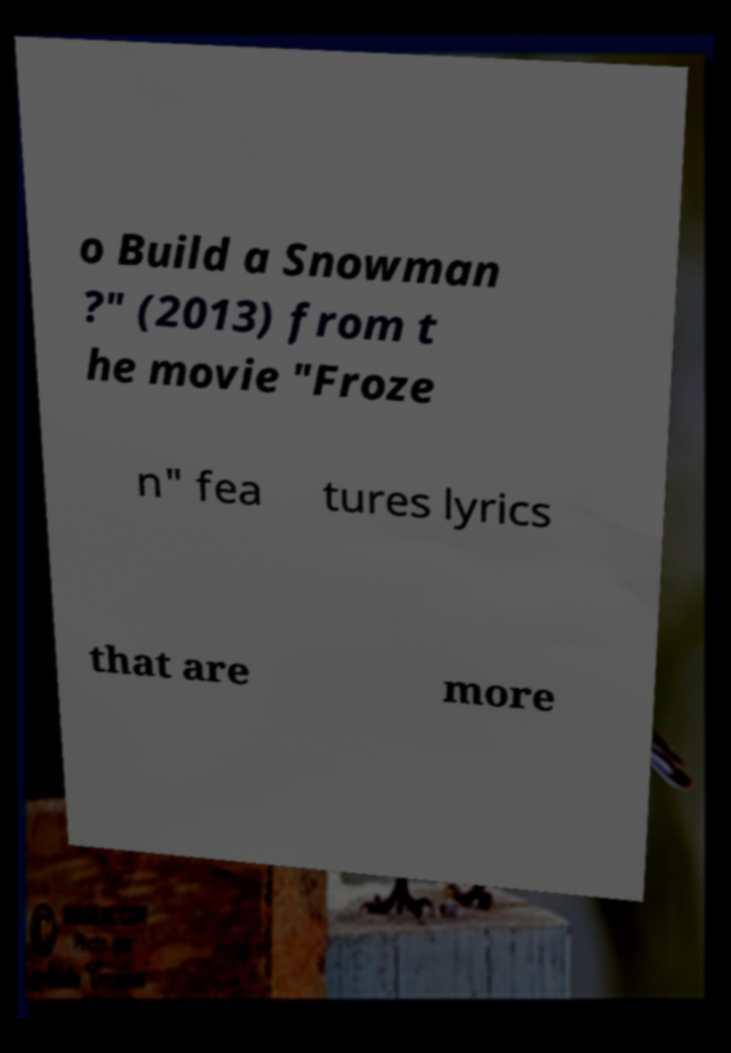Please identify and transcribe the text found in this image. o Build a Snowman ?" (2013) from t he movie "Froze n" fea tures lyrics that are more 